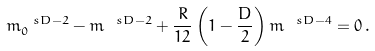Convert formula to latex. <formula><loc_0><loc_0><loc_500><loc_500>m _ { 0 } ^ { \ s D - 2 } - m ^ { \ s D - 2 } + \frac { R } { 1 2 } \left ( 1 - \frac { D } { 2 } \right ) m ^ { \ s D - 4 } = 0 \, .</formula> 